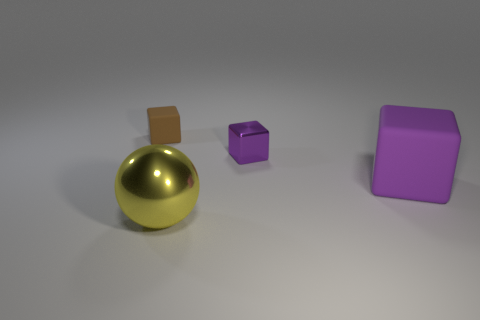Are there any yellow objects that have the same size as the purple matte cube?
Your answer should be compact. Yes. There is a tiny purple thing that is the same shape as the large rubber thing; what is its material?
Your answer should be very brief. Metal. The yellow thing that is the same size as the purple rubber object is what shape?
Keep it short and to the point. Sphere. Are there any tiny purple metal objects that have the same shape as the yellow shiny thing?
Offer a terse response. No. What shape is the large object left of the tiny purple cube on the left side of the large purple rubber cube?
Provide a succinct answer. Sphere. What is the shape of the small purple object?
Make the answer very short. Cube. The small object that is to the right of the matte cube that is to the left of the big object behind the large metallic sphere is made of what material?
Offer a very short reply. Metal. What number of other things are there of the same material as the ball
Provide a succinct answer. 1. What number of things are right of the tiny brown object that is behind the metallic cube?
Your answer should be compact. 3. What number of blocks are either small things or small red rubber things?
Your answer should be compact. 2. 